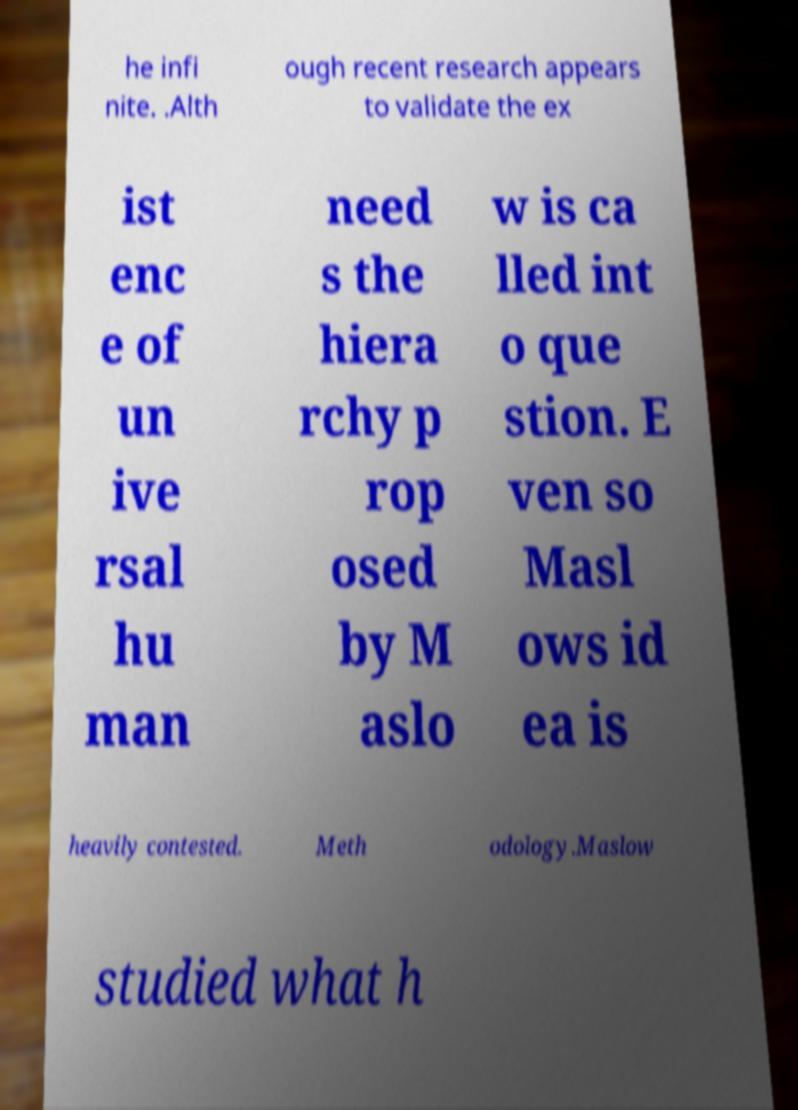Can you accurately transcribe the text from the provided image for me? he infi nite. .Alth ough recent research appears to validate the ex ist enc e of un ive rsal hu man need s the hiera rchy p rop osed by M aslo w is ca lled int o que stion. E ven so Masl ows id ea is heavily contested. Meth odology.Maslow studied what h 